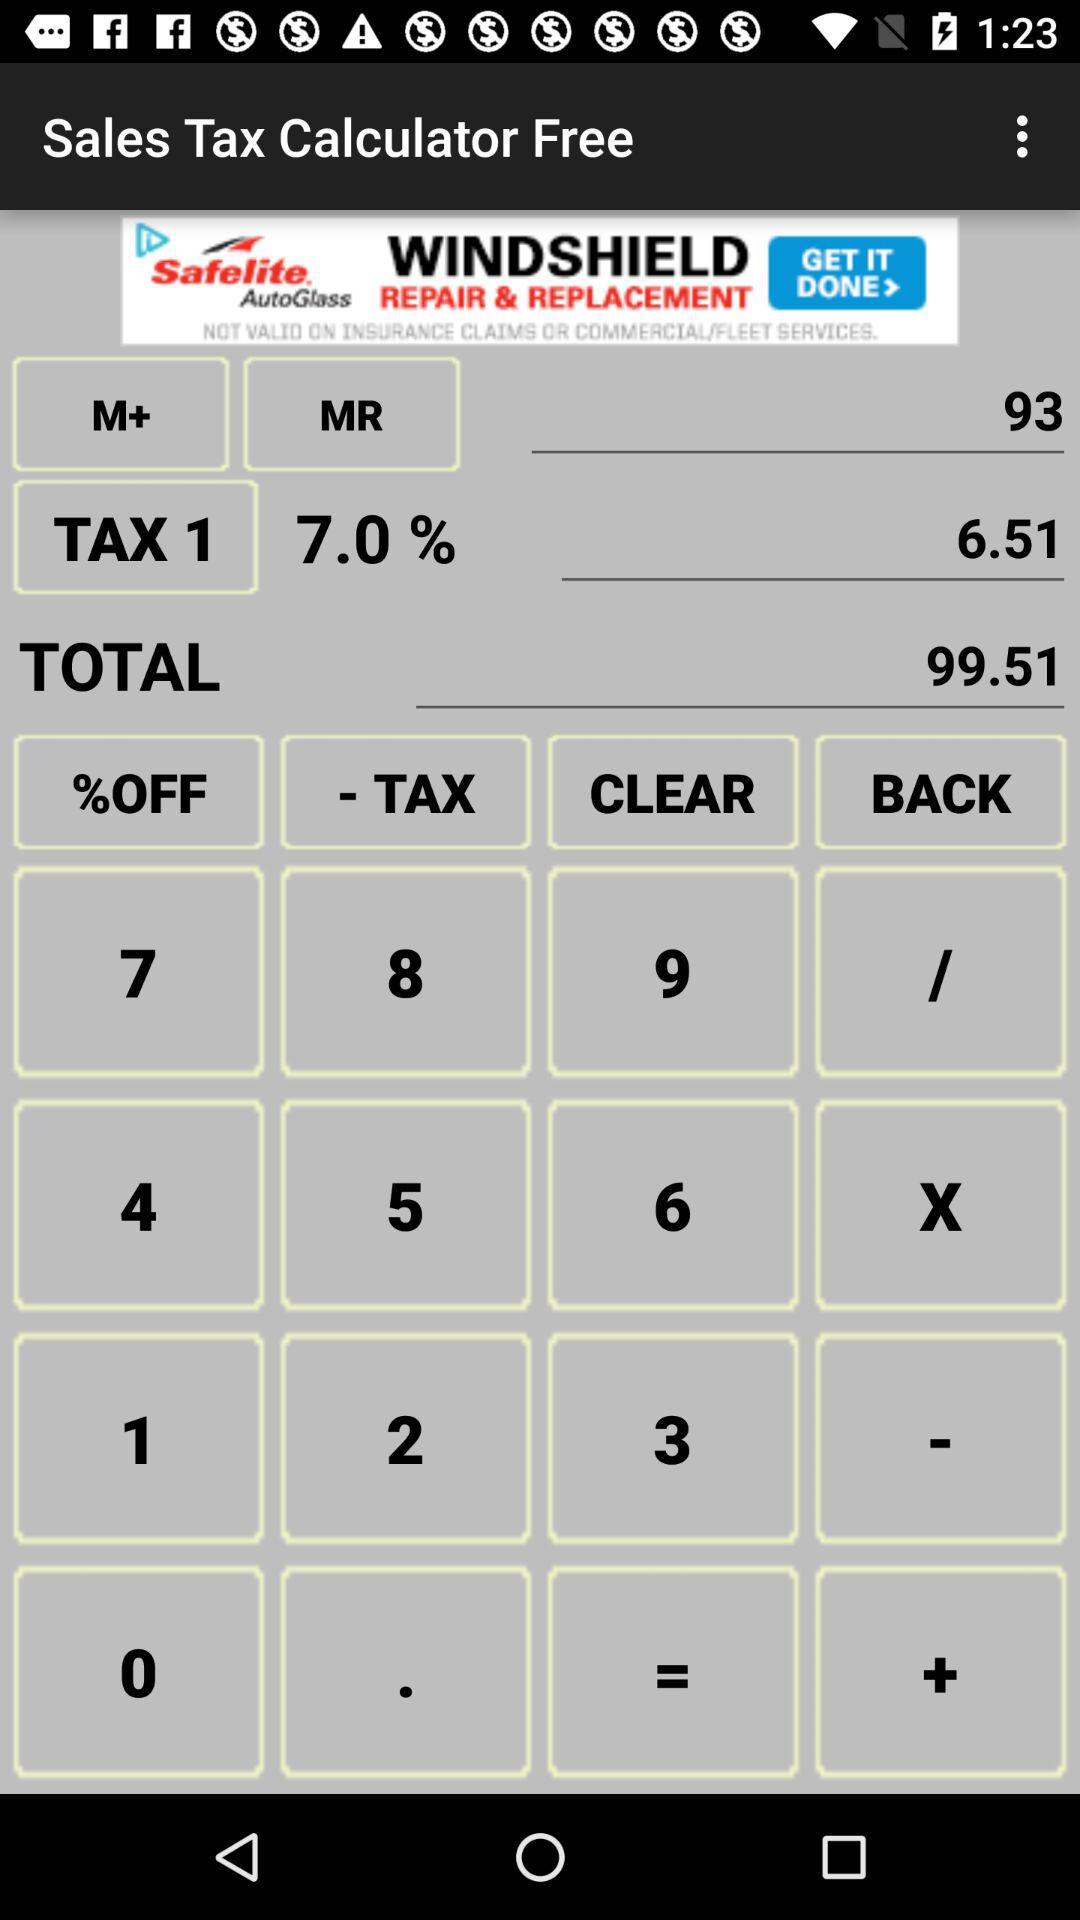How much is the tax on 93?
Answer the question using a single word or phrase. 6.51 